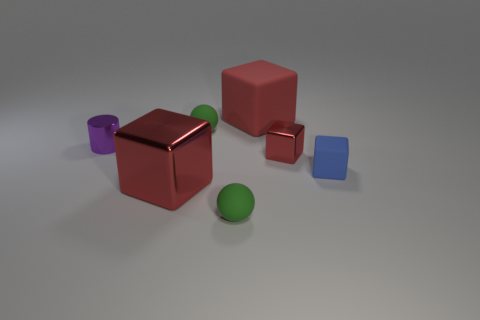Subtract all small rubber cubes. How many cubes are left? 3 Add 3 yellow objects. How many objects exist? 10 Subtract all blue cubes. How many cubes are left? 3 Subtract 1 spheres. How many spheres are left? 1 Subtract all brown cylinders. How many red cubes are left? 3 Subtract all big green rubber spheres. Subtract all tiny purple shiny cylinders. How many objects are left? 6 Add 2 small green balls. How many small green balls are left? 4 Add 7 small yellow cubes. How many small yellow cubes exist? 7 Subtract 0 brown balls. How many objects are left? 7 Subtract all balls. How many objects are left? 5 